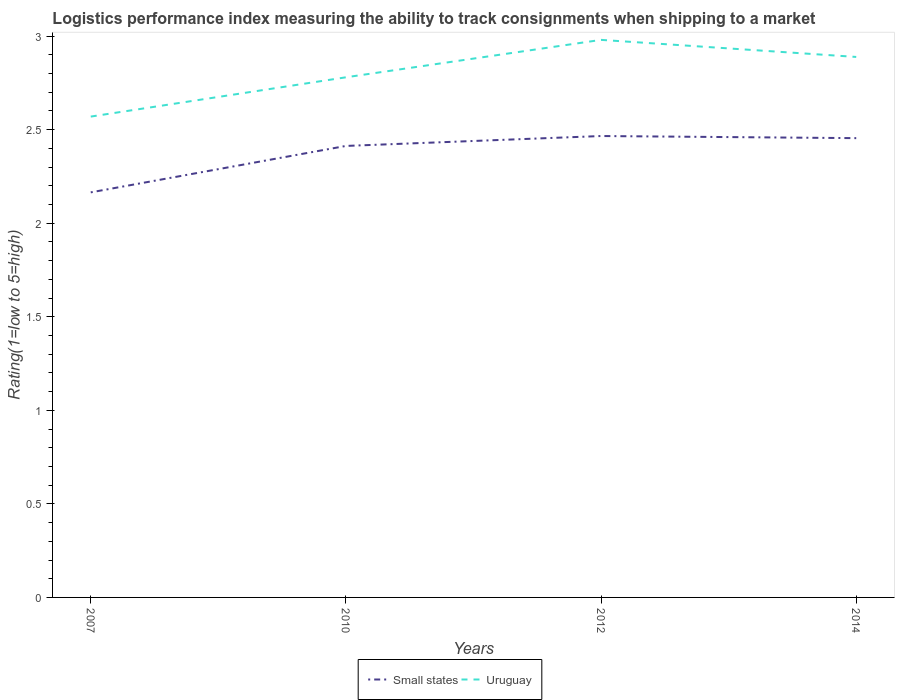Does the line corresponding to Small states intersect with the line corresponding to Uruguay?
Offer a terse response. No. Across all years, what is the maximum Logistic performance index in Small states?
Give a very brief answer. 2.17. What is the total Logistic performance index in Uruguay in the graph?
Keep it short and to the point. -0.41. What is the difference between the highest and the second highest Logistic performance index in Uruguay?
Your answer should be compact. 0.41. How many lines are there?
Offer a very short reply. 2. How many years are there in the graph?
Offer a terse response. 4. Does the graph contain any zero values?
Give a very brief answer. No. Does the graph contain grids?
Your response must be concise. No. Where does the legend appear in the graph?
Your response must be concise. Bottom center. How many legend labels are there?
Provide a short and direct response. 2. How are the legend labels stacked?
Your answer should be compact. Horizontal. What is the title of the graph?
Provide a succinct answer. Logistics performance index measuring the ability to track consignments when shipping to a market. What is the label or title of the Y-axis?
Offer a terse response. Rating(1=low to 5=high). What is the Rating(1=low to 5=high) in Small states in 2007?
Give a very brief answer. 2.17. What is the Rating(1=low to 5=high) in Uruguay in 2007?
Keep it short and to the point. 2.57. What is the Rating(1=low to 5=high) of Small states in 2010?
Give a very brief answer. 2.41. What is the Rating(1=low to 5=high) of Uruguay in 2010?
Offer a terse response. 2.78. What is the Rating(1=low to 5=high) in Small states in 2012?
Offer a very short reply. 2.47. What is the Rating(1=low to 5=high) in Uruguay in 2012?
Give a very brief answer. 2.98. What is the Rating(1=low to 5=high) of Small states in 2014?
Your response must be concise. 2.45. What is the Rating(1=low to 5=high) of Uruguay in 2014?
Keep it short and to the point. 2.89. Across all years, what is the maximum Rating(1=low to 5=high) of Small states?
Offer a terse response. 2.47. Across all years, what is the maximum Rating(1=low to 5=high) in Uruguay?
Your answer should be very brief. 2.98. Across all years, what is the minimum Rating(1=low to 5=high) of Small states?
Ensure brevity in your answer.  2.17. Across all years, what is the minimum Rating(1=low to 5=high) of Uruguay?
Provide a short and direct response. 2.57. What is the total Rating(1=low to 5=high) of Small states in the graph?
Ensure brevity in your answer.  9.5. What is the total Rating(1=low to 5=high) in Uruguay in the graph?
Keep it short and to the point. 11.22. What is the difference between the Rating(1=low to 5=high) of Small states in 2007 and that in 2010?
Ensure brevity in your answer.  -0.25. What is the difference between the Rating(1=low to 5=high) of Uruguay in 2007 and that in 2010?
Your answer should be compact. -0.21. What is the difference between the Rating(1=low to 5=high) of Small states in 2007 and that in 2012?
Make the answer very short. -0.3. What is the difference between the Rating(1=low to 5=high) of Uruguay in 2007 and that in 2012?
Keep it short and to the point. -0.41. What is the difference between the Rating(1=low to 5=high) in Small states in 2007 and that in 2014?
Give a very brief answer. -0.29. What is the difference between the Rating(1=low to 5=high) of Uruguay in 2007 and that in 2014?
Your answer should be compact. -0.32. What is the difference between the Rating(1=low to 5=high) in Small states in 2010 and that in 2012?
Your answer should be very brief. -0.05. What is the difference between the Rating(1=low to 5=high) in Uruguay in 2010 and that in 2012?
Your answer should be compact. -0.2. What is the difference between the Rating(1=low to 5=high) of Small states in 2010 and that in 2014?
Offer a very short reply. -0.04. What is the difference between the Rating(1=low to 5=high) in Uruguay in 2010 and that in 2014?
Your answer should be compact. -0.11. What is the difference between the Rating(1=low to 5=high) in Small states in 2012 and that in 2014?
Your answer should be compact. 0.01. What is the difference between the Rating(1=low to 5=high) of Uruguay in 2012 and that in 2014?
Give a very brief answer. 0.09. What is the difference between the Rating(1=low to 5=high) in Small states in 2007 and the Rating(1=low to 5=high) in Uruguay in 2010?
Your response must be concise. -0.61. What is the difference between the Rating(1=low to 5=high) in Small states in 2007 and the Rating(1=low to 5=high) in Uruguay in 2012?
Offer a very short reply. -0.81. What is the difference between the Rating(1=low to 5=high) of Small states in 2007 and the Rating(1=low to 5=high) of Uruguay in 2014?
Your answer should be very brief. -0.72. What is the difference between the Rating(1=low to 5=high) of Small states in 2010 and the Rating(1=low to 5=high) of Uruguay in 2012?
Offer a terse response. -0.57. What is the difference between the Rating(1=low to 5=high) of Small states in 2010 and the Rating(1=low to 5=high) of Uruguay in 2014?
Ensure brevity in your answer.  -0.48. What is the difference between the Rating(1=low to 5=high) in Small states in 2012 and the Rating(1=low to 5=high) in Uruguay in 2014?
Give a very brief answer. -0.42. What is the average Rating(1=low to 5=high) in Small states per year?
Your answer should be very brief. 2.37. What is the average Rating(1=low to 5=high) of Uruguay per year?
Provide a succinct answer. 2.8. In the year 2007, what is the difference between the Rating(1=low to 5=high) in Small states and Rating(1=low to 5=high) in Uruguay?
Offer a very short reply. -0.41. In the year 2010, what is the difference between the Rating(1=low to 5=high) of Small states and Rating(1=low to 5=high) of Uruguay?
Offer a terse response. -0.37. In the year 2012, what is the difference between the Rating(1=low to 5=high) of Small states and Rating(1=low to 5=high) of Uruguay?
Provide a short and direct response. -0.51. In the year 2014, what is the difference between the Rating(1=low to 5=high) in Small states and Rating(1=low to 5=high) in Uruguay?
Offer a terse response. -0.43. What is the ratio of the Rating(1=low to 5=high) of Small states in 2007 to that in 2010?
Ensure brevity in your answer.  0.9. What is the ratio of the Rating(1=low to 5=high) in Uruguay in 2007 to that in 2010?
Provide a succinct answer. 0.92. What is the ratio of the Rating(1=low to 5=high) of Small states in 2007 to that in 2012?
Ensure brevity in your answer.  0.88. What is the ratio of the Rating(1=low to 5=high) in Uruguay in 2007 to that in 2012?
Ensure brevity in your answer.  0.86. What is the ratio of the Rating(1=low to 5=high) of Small states in 2007 to that in 2014?
Offer a very short reply. 0.88. What is the ratio of the Rating(1=low to 5=high) in Uruguay in 2007 to that in 2014?
Ensure brevity in your answer.  0.89. What is the ratio of the Rating(1=low to 5=high) of Small states in 2010 to that in 2012?
Make the answer very short. 0.98. What is the ratio of the Rating(1=low to 5=high) of Uruguay in 2010 to that in 2012?
Provide a short and direct response. 0.93. What is the ratio of the Rating(1=low to 5=high) in Small states in 2010 to that in 2014?
Ensure brevity in your answer.  0.98. What is the ratio of the Rating(1=low to 5=high) in Uruguay in 2010 to that in 2014?
Give a very brief answer. 0.96. What is the ratio of the Rating(1=low to 5=high) in Small states in 2012 to that in 2014?
Ensure brevity in your answer.  1. What is the ratio of the Rating(1=low to 5=high) of Uruguay in 2012 to that in 2014?
Provide a succinct answer. 1.03. What is the difference between the highest and the second highest Rating(1=low to 5=high) of Small states?
Offer a very short reply. 0.01. What is the difference between the highest and the second highest Rating(1=low to 5=high) in Uruguay?
Your answer should be very brief. 0.09. What is the difference between the highest and the lowest Rating(1=low to 5=high) of Small states?
Give a very brief answer. 0.3. What is the difference between the highest and the lowest Rating(1=low to 5=high) in Uruguay?
Provide a short and direct response. 0.41. 